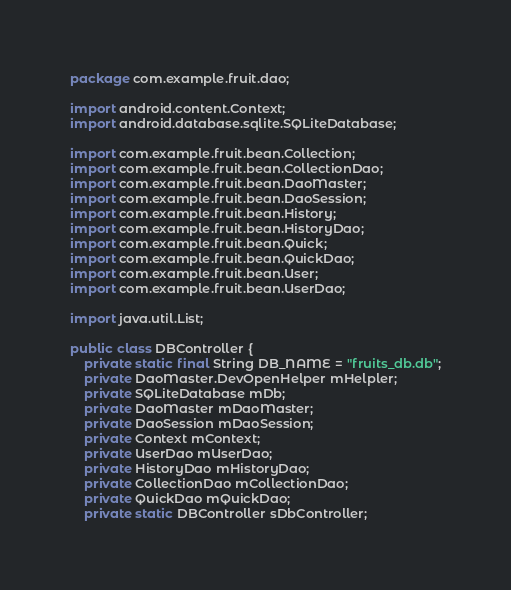<code> <loc_0><loc_0><loc_500><loc_500><_Java_>package com.example.fruit.dao;

import android.content.Context;
import android.database.sqlite.SQLiteDatabase;

import com.example.fruit.bean.Collection;
import com.example.fruit.bean.CollectionDao;
import com.example.fruit.bean.DaoMaster;
import com.example.fruit.bean.DaoSession;
import com.example.fruit.bean.History;
import com.example.fruit.bean.HistoryDao;
import com.example.fruit.bean.Quick;
import com.example.fruit.bean.QuickDao;
import com.example.fruit.bean.User;
import com.example.fruit.bean.UserDao;

import java.util.List;

public class DBController {
    private static final String DB_NAME = "fruits_db.db";
    private DaoMaster.DevOpenHelper mHelpler;
    private SQLiteDatabase mDb;
    private DaoMaster mDaoMaster;
    private DaoSession mDaoSession;
    private Context mContext;
    private UserDao mUserDao;
    private HistoryDao mHistoryDao;
    private CollectionDao mCollectionDao;
    private QuickDao mQuickDao;
    private static DBController sDbController;
</code> 